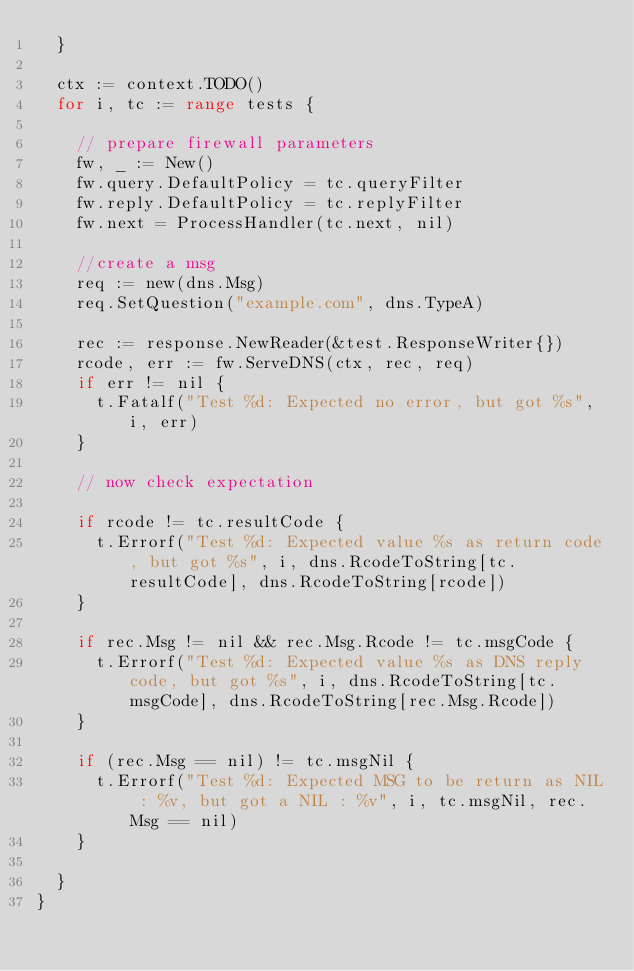<code> <loc_0><loc_0><loc_500><loc_500><_Go_>	}

	ctx := context.TODO()
	for i, tc := range tests {

		// prepare firewall parameters
		fw, _ := New()
		fw.query.DefaultPolicy = tc.queryFilter
		fw.reply.DefaultPolicy = tc.replyFilter
		fw.next = ProcessHandler(tc.next, nil)

		//create a msg
		req := new(dns.Msg)
		req.SetQuestion("example.com", dns.TypeA)

		rec := response.NewReader(&test.ResponseWriter{})
		rcode, err := fw.ServeDNS(ctx, rec, req)
		if err != nil {
			t.Fatalf("Test %d: Expected no error, but got %s", i, err)
		}

		// now check expectation

		if rcode != tc.resultCode {
			t.Errorf("Test %d: Expected value %s as return code, but got %s", i, dns.RcodeToString[tc.resultCode], dns.RcodeToString[rcode])
		}

		if rec.Msg != nil && rec.Msg.Rcode != tc.msgCode {
			t.Errorf("Test %d: Expected value %s as DNS reply code, but got %s", i, dns.RcodeToString[tc.msgCode], dns.RcodeToString[rec.Msg.Rcode])
		}

		if (rec.Msg == nil) != tc.msgNil {
			t.Errorf("Test %d: Expected MSG to be return as NIL : %v, but got a NIL : %v", i, tc.msgNil, rec.Msg == nil)
		}

	}
}
</code> 